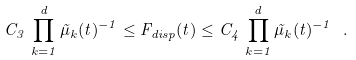<formula> <loc_0><loc_0><loc_500><loc_500>C _ { 3 } \, \prod _ { k = 1 } ^ { d } \tilde { \mu } _ { k } ( t ) ^ { - 1 } \leq F _ { d i s p } ( t ) \leq C _ { 4 } \, \prod _ { k = 1 } ^ { d } \tilde { \mu } _ { k } ( t ) ^ { - 1 } \ .</formula> 